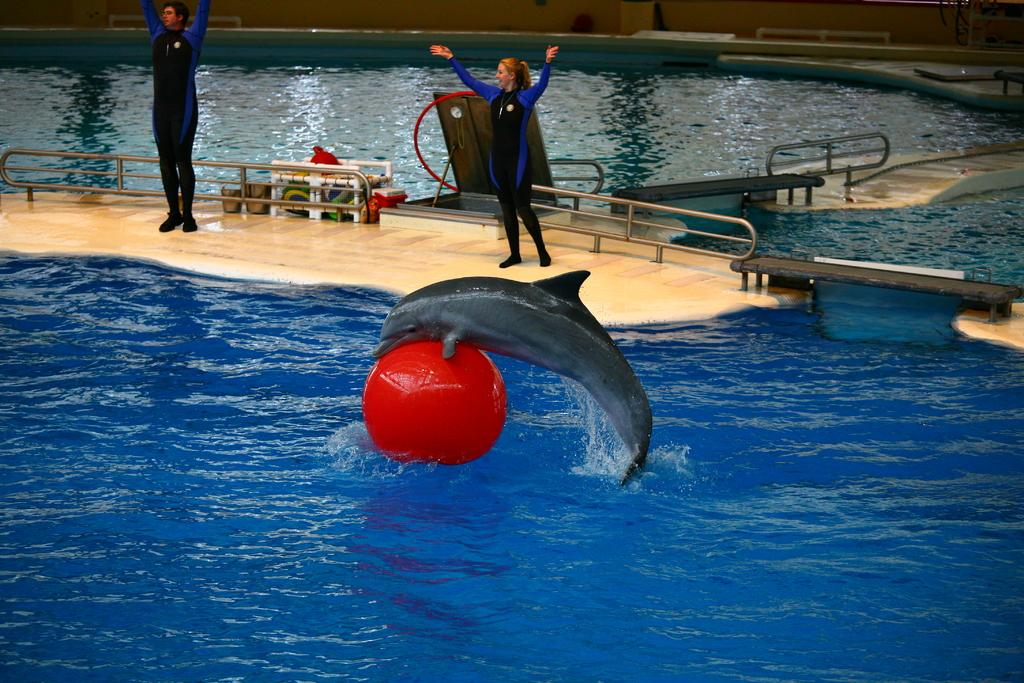What animal can be seen in the picture? There is a dolphin in the picture. What object is floating on the water? There is a red ball on the water. How many people are standing on the surface? There are two people standing on the surface. What feature can be seen around the area? Railings are visible in the picture. Are the dolphin and the red ball friends in the image? There is no indication in the image that the dolphin and the red ball have a relationship or are friends. 